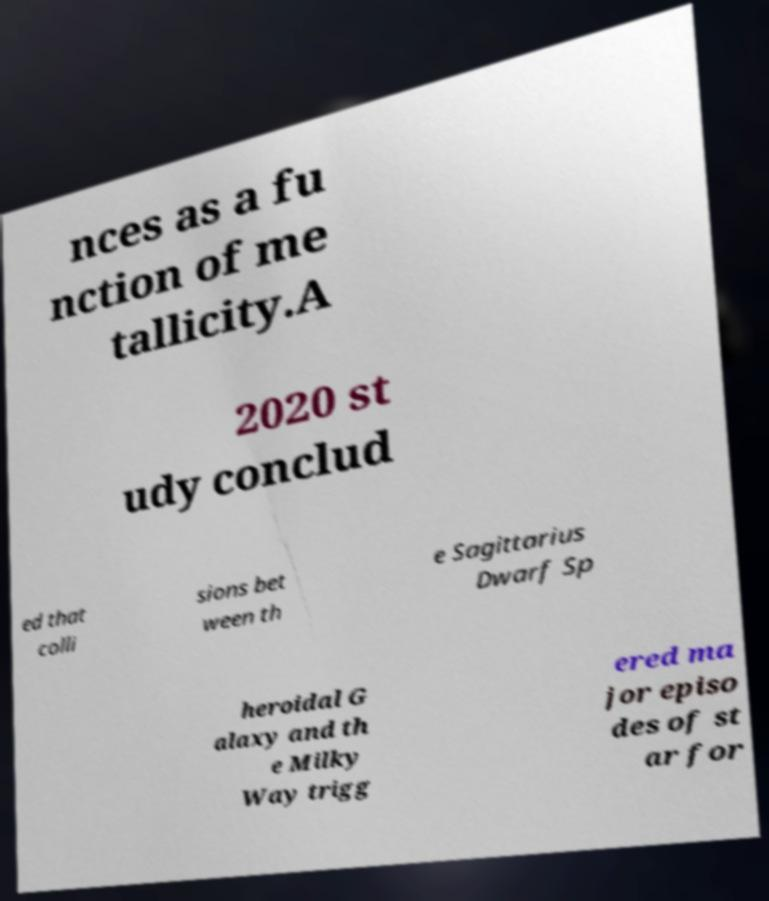I need the written content from this picture converted into text. Can you do that? nces as a fu nction of me tallicity.A 2020 st udy conclud ed that colli sions bet ween th e Sagittarius Dwarf Sp heroidal G alaxy and th e Milky Way trigg ered ma jor episo des of st ar for 